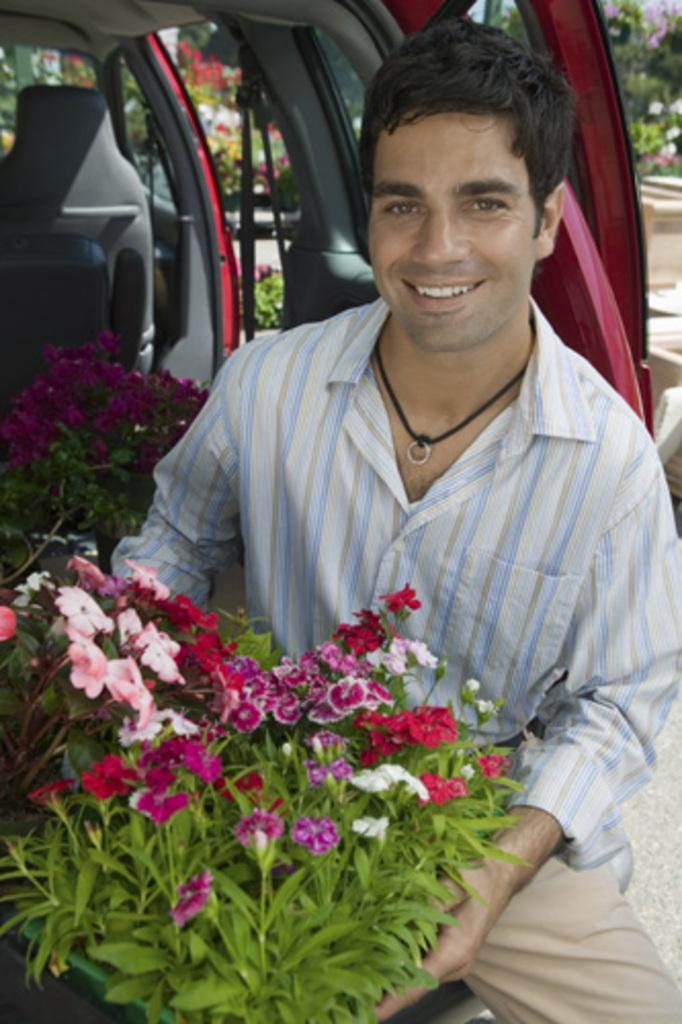Who is present in the image? There is a man in the image. What is the man's facial expression? The man is smiling. What type of plants can be seen in the image? There are plants with flowers in the image. What mode of transportation is visible in the image? There is a vehicle in the image. What can be seen in the background of the image? There are trees and other objects visible in the background of the image. What type of underwear is the man wearing in the image? There is no information about the man's underwear in the image, so it cannot be determined. 